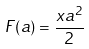<formula> <loc_0><loc_0><loc_500><loc_500>F ( a ) = \frac { x a ^ { 2 } } { 2 }</formula> 